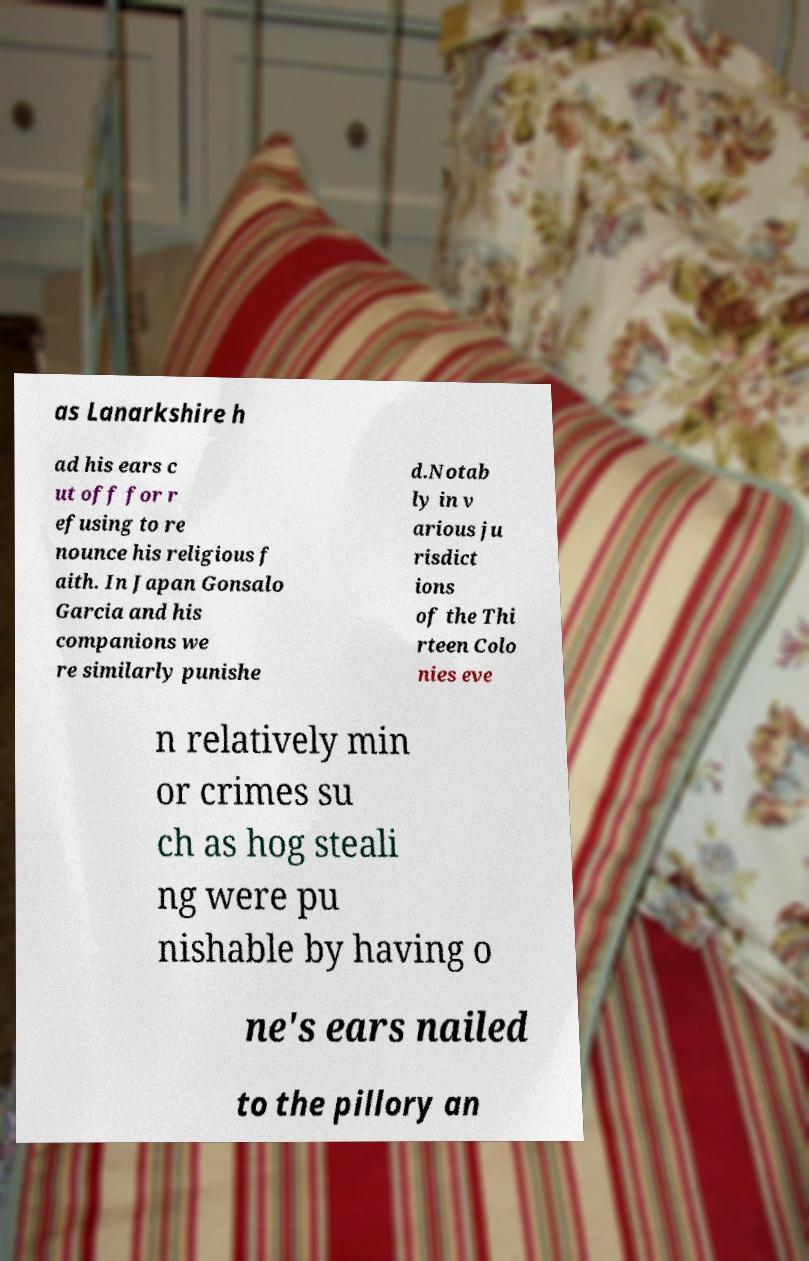Could you assist in decoding the text presented in this image and type it out clearly? as Lanarkshire h ad his ears c ut off for r efusing to re nounce his religious f aith. In Japan Gonsalo Garcia and his companions we re similarly punishe d.Notab ly in v arious ju risdict ions of the Thi rteen Colo nies eve n relatively min or crimes su ch as hog steali ng were pu nishable by having o ne's ears nailed to the pillory an 